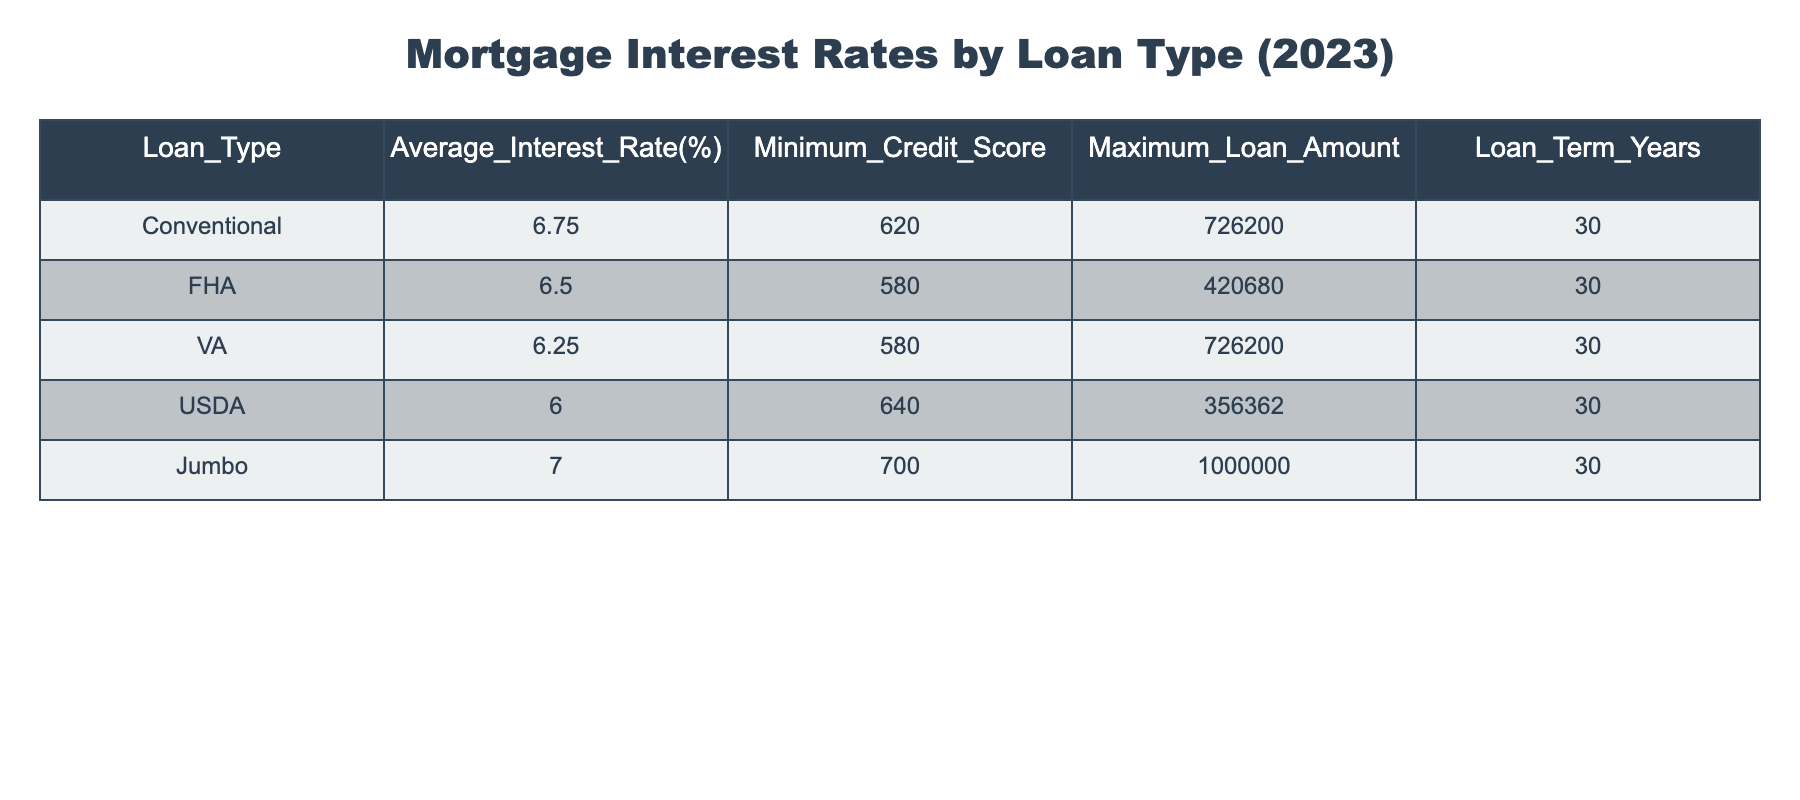What is the average interest rate for FHA loans? The table shows that the Average Interest Rate for FHA loans is 6.50%.
Answer: 6.50% Which loan type has the highest maximum loan amount? By examining the Maximum Loan Amount column, both Conventional and VA loan types have a maximum loan amount of 726200, which is higher than the others.
Answer: Conventional and VA Does the USDA loan require a higher minimum credit score than the VA loan? The Minimum Credit Score for USDA loans is 640, while for VA loans, it is 580. Therefore, USDA does require a higher minimum credit score.
Answer: Yes What is the difference in average interest rates between Jumbo and USDA loans? The Average Interest Rate for Jumbo loans is 7.00%, and for USDA loans, it is 6.00%. The difference is 7.00 - 6.00 = 1.00%.
Answer: 1.00% Which loan type has the lowest average interest rate? Looking at the Average Interest Rate column, the VA loan type has the lowest average interest rate at 6.25%.
Answer: VA If someone has a credit score of 620, what types of loans are they eligible for? A minimum credit score of 620 allows for Conventional loans, and since FHA and VA loans have lower minimum credit scores (580), they are also accessible.
Answer: Conventional, FHA, and VA What is the average interest rate for all loan types combined? To find the average, sum the Average Interest Rates: (6.75 + 6.50 + 6.25 + 6.00 + 7.00) = 32.50%. Then divide by the number of loan types (5), giving 32.50 / 5 = 6.50%.
Answer: 6.50% Is it true that all loan types have the same loan term duration? All listed loan types have a Loan Term of 30 years, indicating they are the same duration.
Answer: Yes Which loan type has the highest interest rate, and what is that rate? The Jumbo loan type has the highest average interest rate at 7.00%.
Answer: Jumbo at 7.00% 